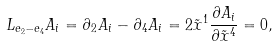Convert formula to latex. <formula><loc_0><loc_0><loc_500><loc_500>L _ { e _ { 2 } - e _ { 4 } } A _ { i } = \partial _ { 2 } A _ { i } - \partial _ { 4 } A _ { i } = 2 \tilde { x } ^ { 1 } \frac { \partial A _ { i } } { \partial \tilde { x } ^ { 4 } } = 0 ,</formula> 